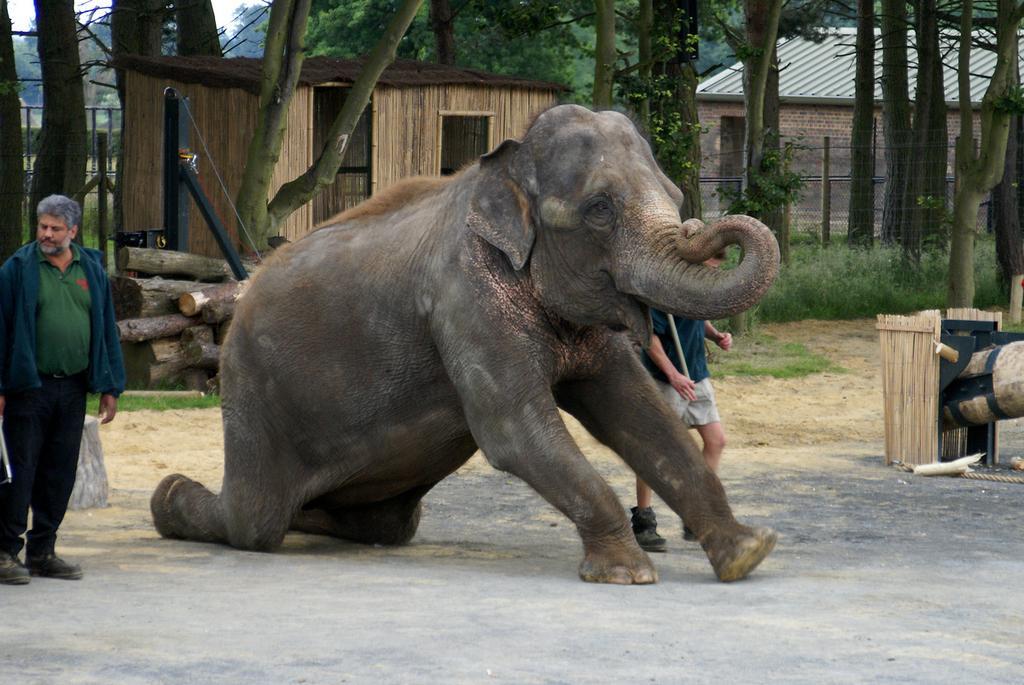Can you describe this image briefly? We can see an elephant is standing on the knees by its backside two legs on the ground. To the left and right we can see two men standing on the ground. In the background there are trees, plants, grass, windows, wooden objects, wall, fence, roof, house and sky. 